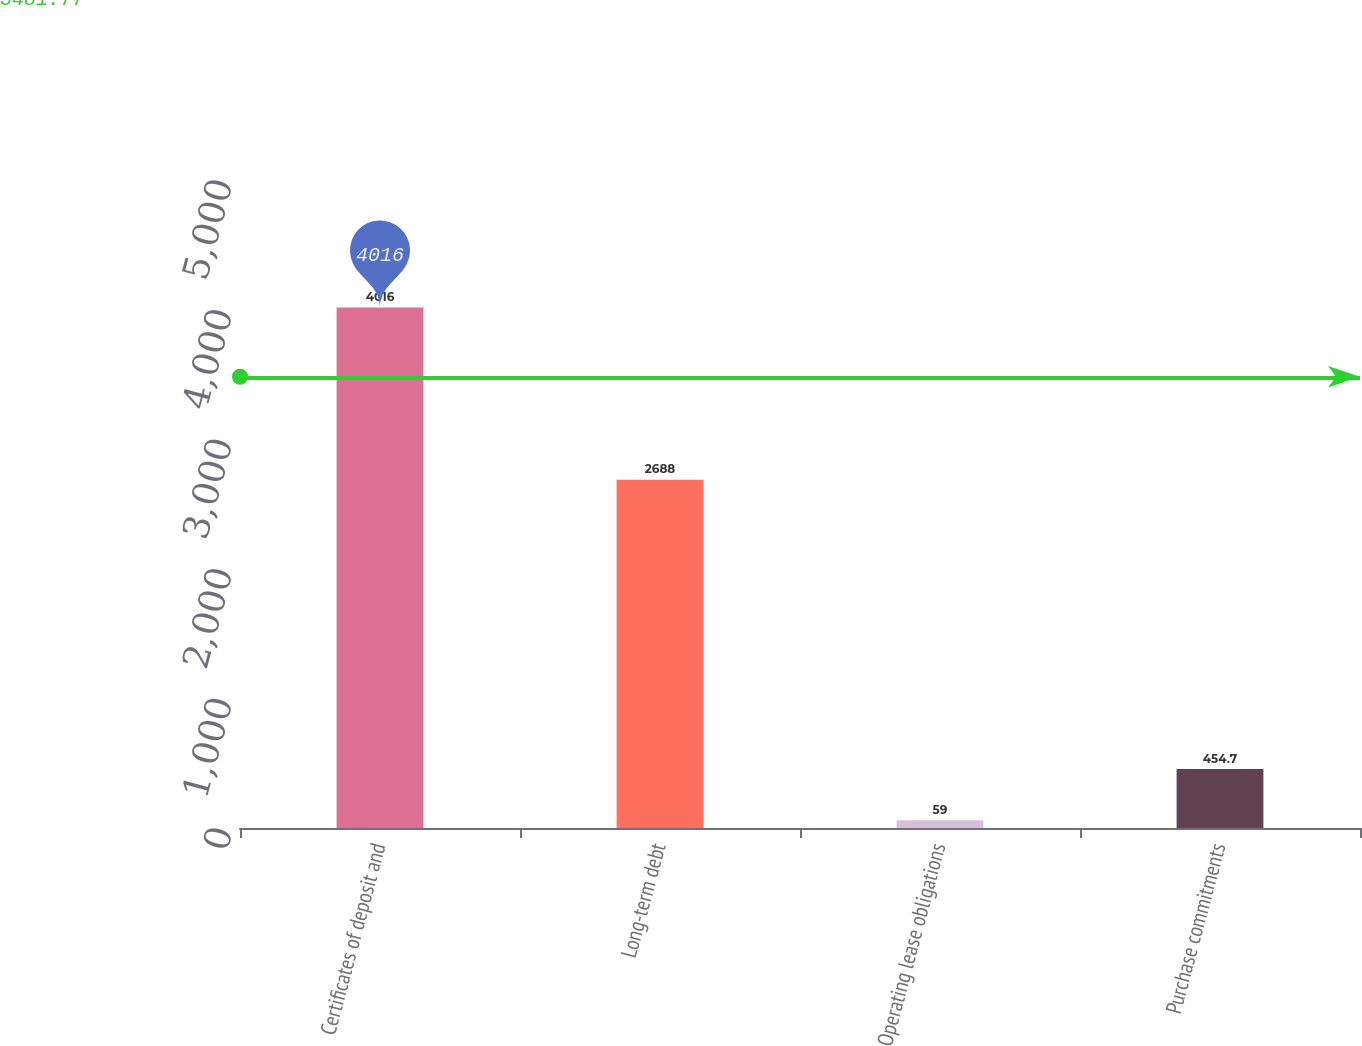Convert chart. <chart><loc_0><loc_0><loc_500><loc_500><bar_chart><fcel>Certificates of deposit and<fcel>Long-term debt<fcel>Operating lease obligations<fcel>Purchase commitments<nl><fcel>4016<fcel>2688<fcel>59<fcel>454.7<nl></chart> 